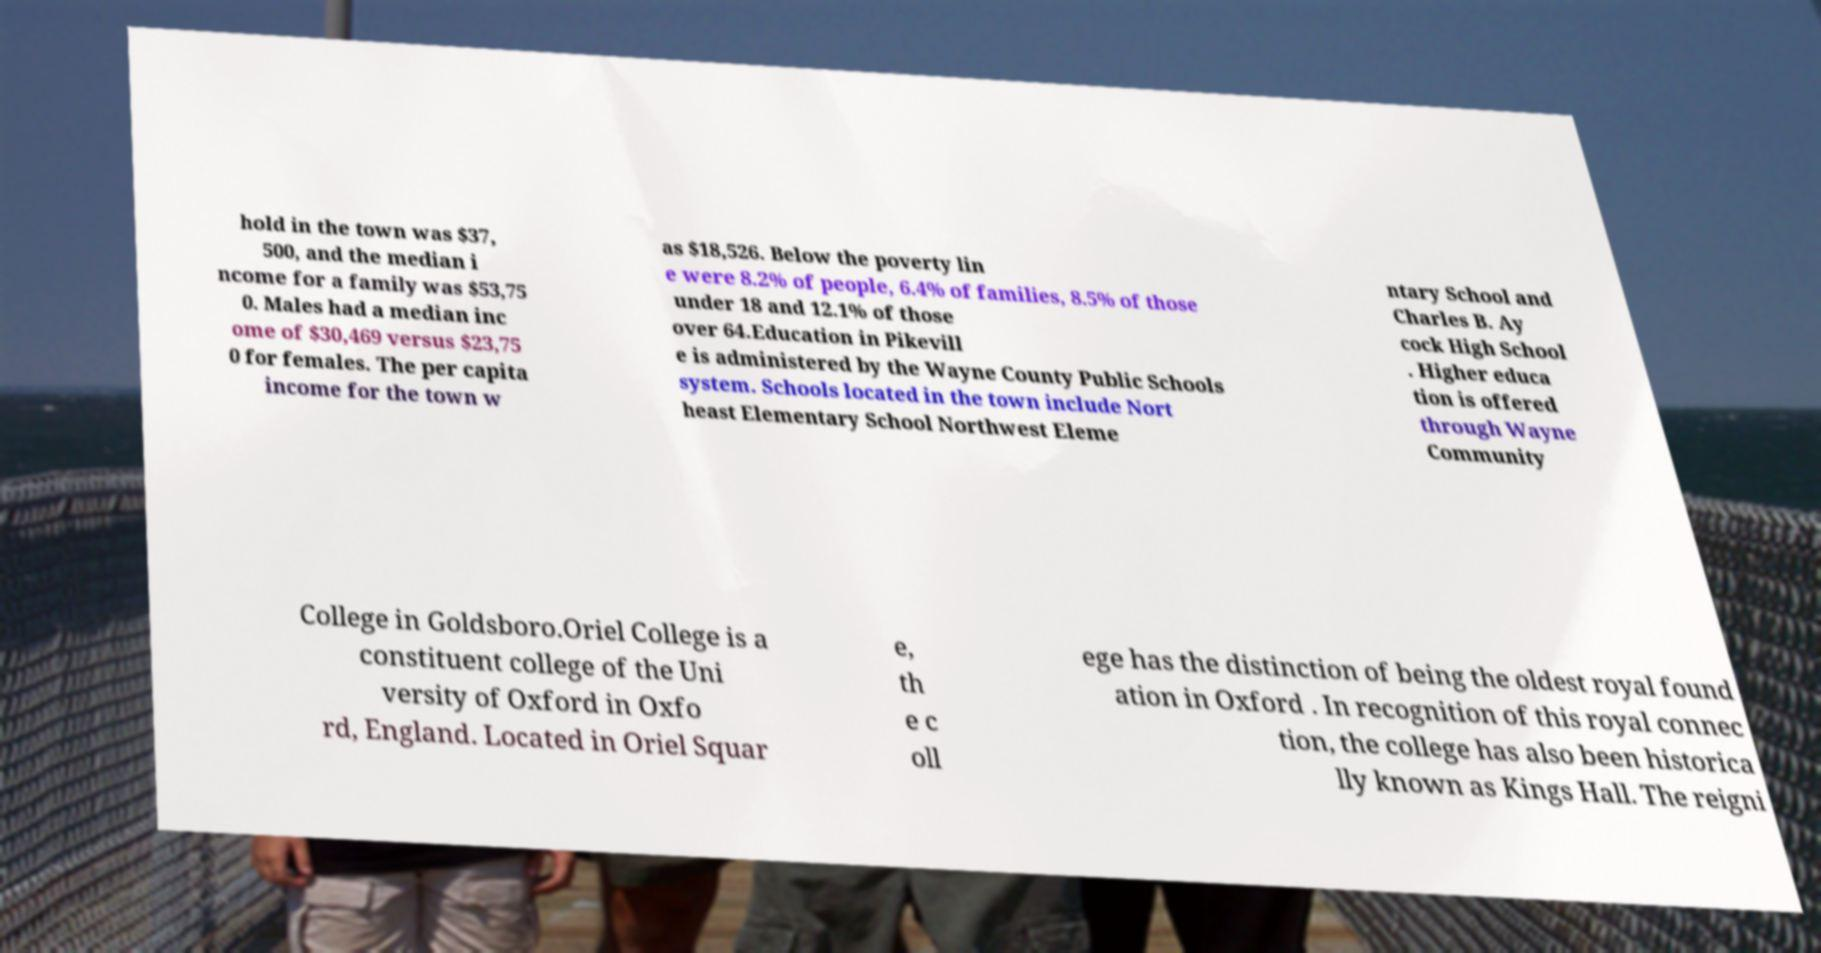What messages or text are displayed in this image? I need them in a readable, typed format. hold in the town was $37, 500, and the median i ncome for a family was $53,75 0. Males had a median inc ome of $30,469 versus $23,75 0 for females. The per capita income for the town w as $18,526. Below the poverty lin e were 8.2% of people, 6.4% of families, 8.5% of those under 18 and 12.1% of those over 64.Education in Pikevill e is administered by the Wayne County Public Schools system. Schools located in the town include Nort heast Elementary School Northwest Eleme ntary School and Charles B. Ay cock High School . Higher educa tion is offered through Wayne Community College in Goldsboro.Oriel College is a constituent college of the Uni versity of Oxford in Oxfo rd, England. Located in Oriel Squar e, th e c oll ege has the distinction of being the oldest royal found ation in Oxford . In recognition of this royal connec tion, the college has also been historica lly known as Kings Hall. The reigni 